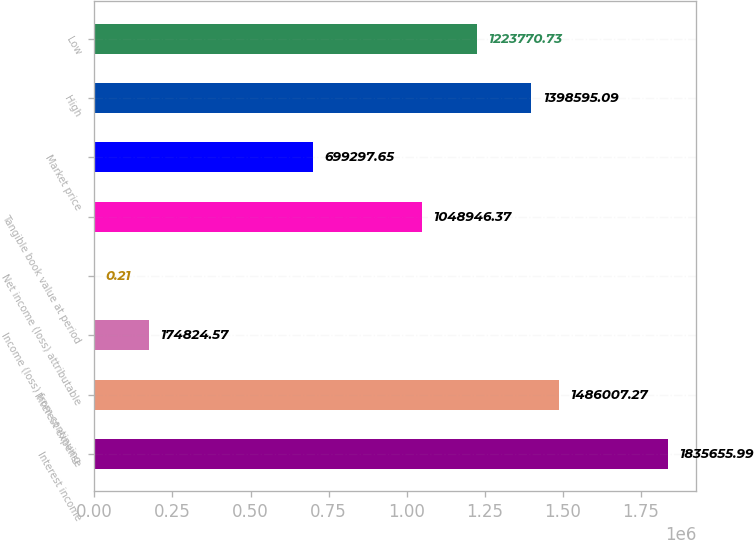Convert chart. <chart><loc_0><loc_0><loc_500><loc_500><bar_chart><fcel>Interest income<fcel>Interest expense<fcel>Income (loss) from continuing<fcel>Net income (loss) attributable<fcel>Tangible book value at period<fcel>Market price<fcel>High<fcel>Low<nl><fcel>1.83566e+06<fcel>1.48601e+06<fcel>174825<fcel>0.21<fcel>1.04895e+06<fcel>699298<fcel>1.3986e+06<fcel>1.22377e+06<nl></chart> 